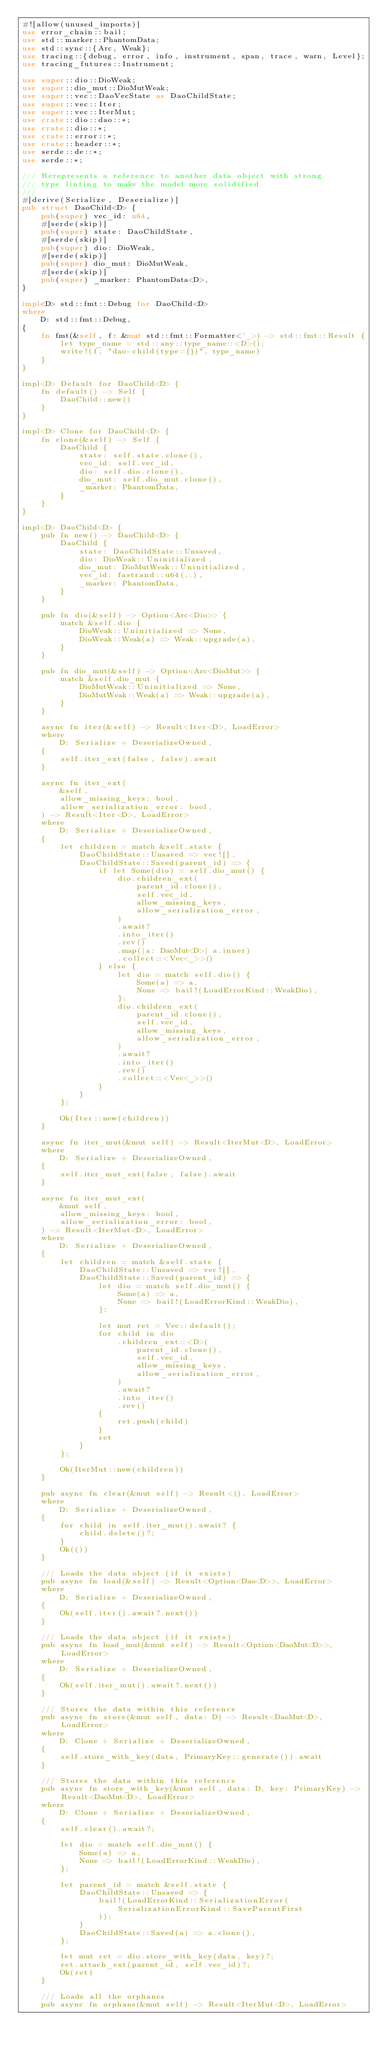<code> <loc_0><loc_0><loc_500><loc_500><_Rust_>#![allow(unused_imports)]
use error_chain::bail;
use std::marker::PhantomData;
use std::sync::{Arc, Weak};
use tracing::{debug, error, info, instrument, span, trace, warn, Level};
use tracing_futures::Instrument;

use super::dio::DioWeak;
use super::dio_mut::DioMutWeak;
use super::vec::DaoVecState as DaoChildState;
use super::vec::Iter;
use super::vec::IterMut;
use crate::dio::dao::*;
use crate::dio::*;
use crate::error::*;
use crate::header::*;
use serde::de::*;
use serde::*;

/// Rerepresents a reference to another data object with strong
/// type linting to make the model more solidified
///
#[derive(Serialize, Deserialize)]
pub struct DaoChild<D> {
    pub(super) vec_id: u64,
    #[serde(skip)]
    pub(super) state: DaoChildState,
    #[serde(skip)]
    pub(super) dio: DioWeak,
    #[serde(skip)]
    pub(super) dio_mut: DioMutWeak,
    #[serde(skip)]
    pub(super) _marker: PhantomData<D>,
}

impl<D> std::fmt::Debug for DaoChild<D>
where
    D: std::fmt::Debug,
{
    fn fmt(&self, f: &mut std::fmt::Formatter<'_>) -> std::fmt::Result {
        let type_name = std::any::type_name::<D>();
        write!(f, "dao-child(type={})", type_name)
    }
}

impl<D> Default for DaoChild<D> {
    fn default() -> Self {
        DaoChild::new()
    }
}

impl<D> Clone for DaoChild<D> {
    fn clone(&self) -> Self {
        DaoChild {
            state: self.state.clone(),
            vec_id: self.vec_id,
            dio: self.dio.clone(),
            dio_mut: self.dio_mut.clone(),
            _marker: PhantomData,
        }
    }
}

impl<D> DaoChild<D> {
    pub fn new() -> DaoChild<D> {
        DaoChild {
            state: DaoChildState::Unsaved,
            dio: DioWeak::Uninitialized,
            dio_mut: DioMutWeak::Uninitialized,
            vec_id: fastrand::u64(..),
            _marker: PhantomData,
        }
    }

    pub fn dio(&self) -> Option<Arc<Dio>> {
        match &self.dio {
            DioWeak::Uninitialized => None,
            DioWeak::Weak(a) => Weak::upgrade(a),
        }
    }

    pub fn dio_mut(&self) -> Option<Arc<DioMut>> {
        match &self.dio_mut {
            DioMutWeak::Uninitialized => None,
            DioMutWeak::Weak(a) => Weak::upgrade(a),
        }
    }

    async fn iter(&self) -> Result<Iter<D>, LoadError>
    where
        D: Serialize + DeserializeOwned,
    {
        self.iter_ext(false, false).await
    }

    async fn iter_ext(
        &self,
        allow_missing_keys: bool,
        allow_serialization_error: bool,
    ) -> Result<Iter<D>, LoadError>
    where
        D: Serialize + DeserializeOwned,
    {
        let children = match &self.state {
            DaoChildState::Unsaved => vec![],
            DaoChildState::Saved(parent_id) => {
                if let Some(dio) = self.dio_mut() {
                    dio.children_ext(
                        parent_id.clone(),
                        self.vec_id,
                        allow_missing_keys,
                        allow_serialization_error,
                    )
                    .await?
                    .into_iter()
                    .rev()
                    .map(|a: DaoMut<D>| a.inner)
                    .collect::<Vec<_>>()
                } else {
                    let dio = match self.dio() {
                        Some(a) => a,
                        None => bail!(LoadErrorKind::WeakDio),
                    };
                    dio.children_ext(
                        parent_id.clone(),
                        self.vec_id,
                        allow_missing_keys,
                        allow_serialization_error,
                    )
                    .await?
                    .into_iter()
                    .rev()
                    .collect::<Vec<_>>()
                }
            }
        };

        Ok(Iter::new(children))
    }

    async fn iter_mut(&mut self) -> Result<IterMut<D>, LoadError>
    where
        D: Serialize + DeserializeOwned,
    {
        self.iter_mut_ext(false, false).await
    }

    async fn iter_mut_ext(
        &mut self,
        allow_missing_keys: bool,
        allow_serialization_error: bool,
    ) -> Result<IterMut<D>, LoadError>
    where
        D: Serialize + DeserializeOwned,
    {
        let children = match &self.state {
            DaoChildState::Unsaved => vec![],
            DaoChildState::Saved(parent_id) => {
                let dio = match self.dio_mut() {
                    Some(a) => a,
                    None => bail!(LoadErrorKind::WeakDio),
                };

                let mut ret = Vec::default();
                for child in dio
                    .children_ext::<D>(
                        parent_id.clone(),
                        self.vec_id,
                        allow_missing_keys,
                        allow_serialization_error,
                    )
                    .await?
                    .into_iter()
                    .rev()
                {
                    ret.push(child)
                }
                ret
            }
        };

        Ok(IterMut::new(children))
    }

    pub async fn clear(&mut self) -> Result<(), LoadError>
    where
        D: Serialize + DeserializeOwned,
    {
        for child in self.iter_mut().await? {
            child.delete()?;
        }
        Ok(())
    }

    /// Loads the data object (if it exists)
    pub async fn load(&self) -> Result<Option<Dao<D>>, LoadError>
    where
        D: Serialize + DeserializeOwned,
    {
        Ok(self.iter().await?.next())
    }

    /// Loads the data object (if it exists)
    pub async fn load_mut(&mut self) -> Result<Option<DaoMut<D>>, LoadError>
    where
        D: Serialize + DeserializeOwned,
    {
        Ok(self.iter_mut().await?.next())
    }

    /// Stores the data within this reference
    pub async fn store(&mut self, data: D) -> Result<DaoMut<D>, LoadError>
    where
        D: Clone + Serialize + DeserializeOwned,
    {
        self.store_with_key(data, PrimaryKey::generate()).await
    }

    /// Stores the data within this reference
    pub async fn store_with_key(&mut self, data: D, key: PrimaryKey) -> Result<DaoMut<D>, LoadError>
    where
        D: Clone + Serialize + DeserializeOwned,
    {
        self.clear().await?;

        let dio = match self.dio_mut() {
            Some(a) => a,
            None => bail!(LoadErrorKind::WeakDio),
        };

        let parent_id = match &self.state {
            DaoChildState::Unsaved => {
                bail!(LoadErrorKind::SerializationError(
                    SerializationErrorKind::SaveParentFirst
                ));
            }
            DaoChildState::Saved(a) => a.clone(),
        };

        let mut ret = dio.store_with_key(data, key)?;
        ret.attach_ext(parent_id, self.vec_id)?;
        Ok(ret)
    }

    /// Loads all the orphanes
    pub async fn orphans(&mut self) -> Result<IterMut<D>, LoadError></code> 